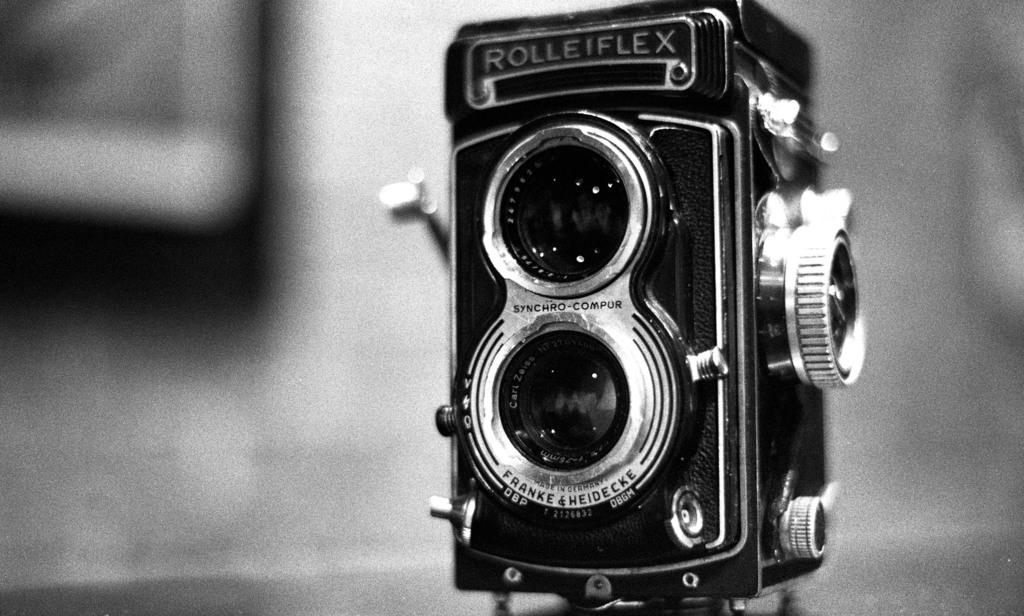What is the color scheme of the image? The image is black and white. What is the main subject of the image? There is a camera in the image. Is there any text visible on the camera? Yes, there is text written on the camera. Can you describe the background of the image? The background of the image is blurry. Where is the nest located in the image? There is no nest present in the image. What type of home is visible in the image? There is no home present in the image. 